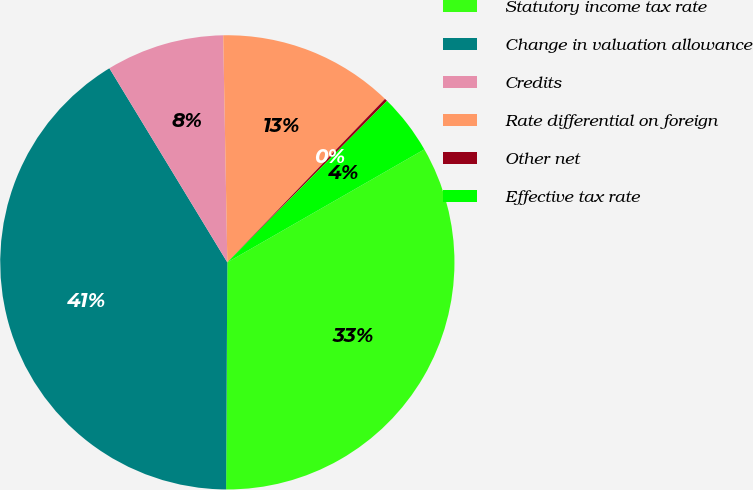Convert chart. <chart><loc_0><loc_0><loc_500><loc_500><pie_chart><fcel>Statutory income tax rate<fcel>Change in valuation allowance<fcel>Credits<fcel>Rate differential on foreign<fcel>Other net<fcel>Effective tax rate<nl><fcel>33.37%<fcel>41.22%<fcel>8.4%<fcel>12.5%<fcel>0.2%<fcel>4.3%<nl></chart> 